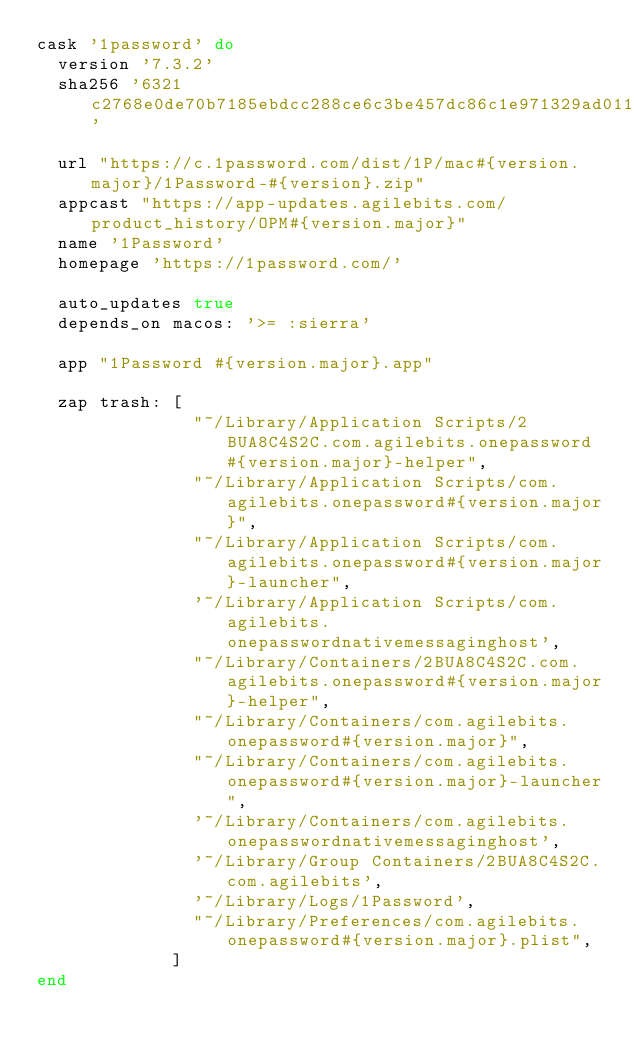Convert code to text. <code><loc_0><loc_0><loc_500><loc_500><_Ruby_>cask '1password' do
  version '7.3.2'
  sha256 '6321c2768e0de70b7185ebdcc288ce6c3be457dc86c1e971329ad011272a8da1'

  url "https://c.1password.com/dist/1P/mac#{version.major}/1Password-#{version}.zip"
  appcast "https://app-updates.agilebits.com/product_history/OPM#{version.major}"
  name '1Password'
  homepage 'https://1password.com/'

  auto_updates true
  depends_on macos: '>= :sierra'

  app "1Password #{version.major}.app"

  zap trash: [
               "~/Library/Application Scripts/2BUA8C4S2C.com.agilebits.onepassword#{version.major}-helper",
               "~/Library/Application Scripts/com.agilebits.onepassword#{version.major}",
               "~/Library/Application Scripts/com.agilebits.onepassword#{version.major}-launcher",
               '~/Library/Application Scripts/com.agilebits.onepasswordnativemessaginghost',
               "~/Library/Containers/2BUA8C4S2C.com.agilebits.onepassword#{version.major}-helper",
               "~/Library/Containers/com.agilebits.onepassword#{version.major}",
               "~/Library/Containers/com.agilebits.onepassword#{version.major}-launcher",
               '~/Library/Containers/com.agilebits.onepasswordnativemessaginghost',
               '~/Library/Group Containers/2BUA8C4S2C.com.agilebits',
               '~/Library/Logs/1Password',
               "~/Library/Preferences/com.agilebits.onepassword#{version.major}.plist",
             ]
end
</code> 